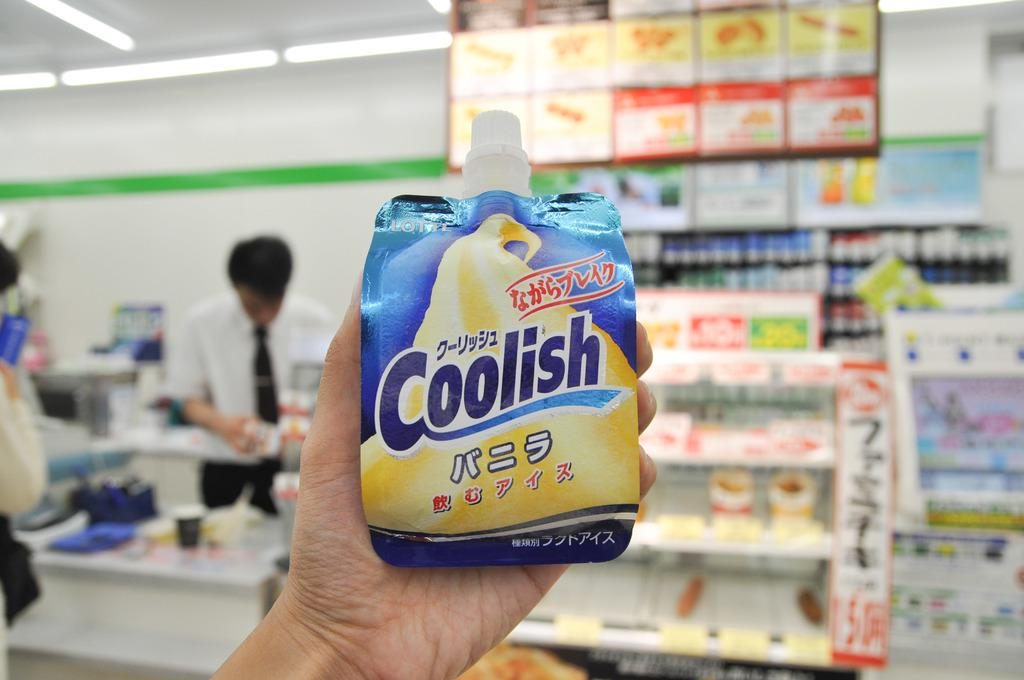<image>
Create a compact narrative representing the image presented. a bottle that has the word coolish written on it 